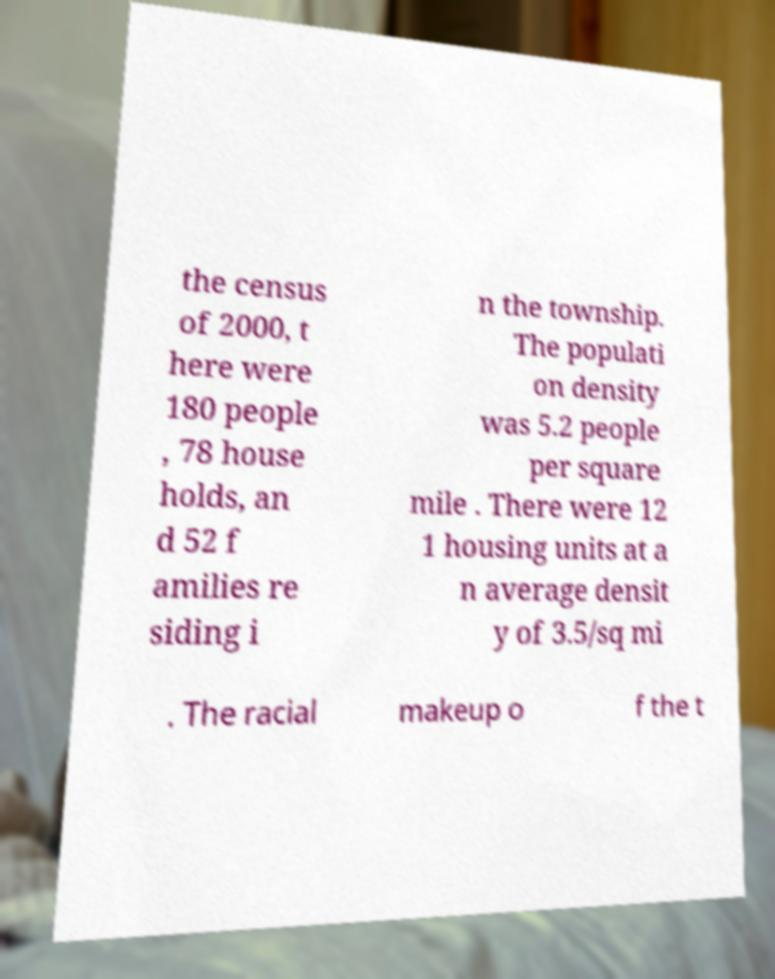Please identify and transcribe the text found in this image. the census of 2000, t here were 180 people , 78 house holds, an d 52 f amilies re siding i n the township. The populati on density was 5.2 people per square mile . There were 12 1 housing units at a n average densit y of 3.5/sq mi . The racial makeup o f the t 